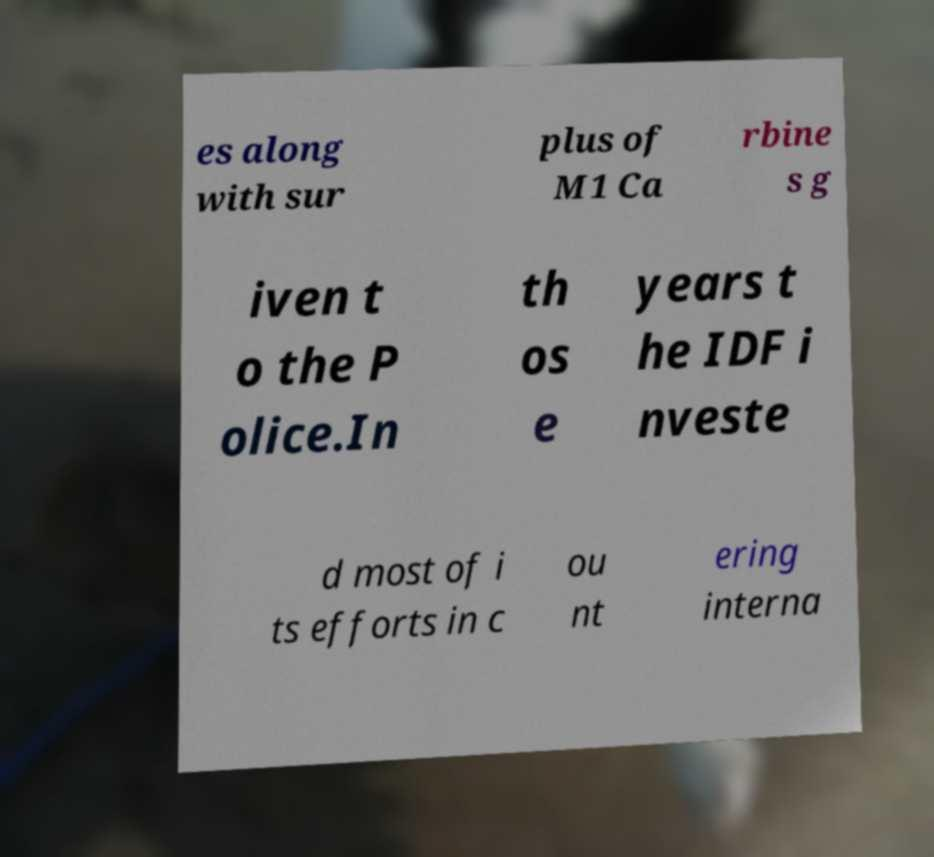Can you accurately transcribe the text from the provided image for me? es along with sur plus of M1 Ca rbine s g iven t o the P olice.In th os e years t he IDF i nveste d most of i ts efforts in c ou nt ering interna 